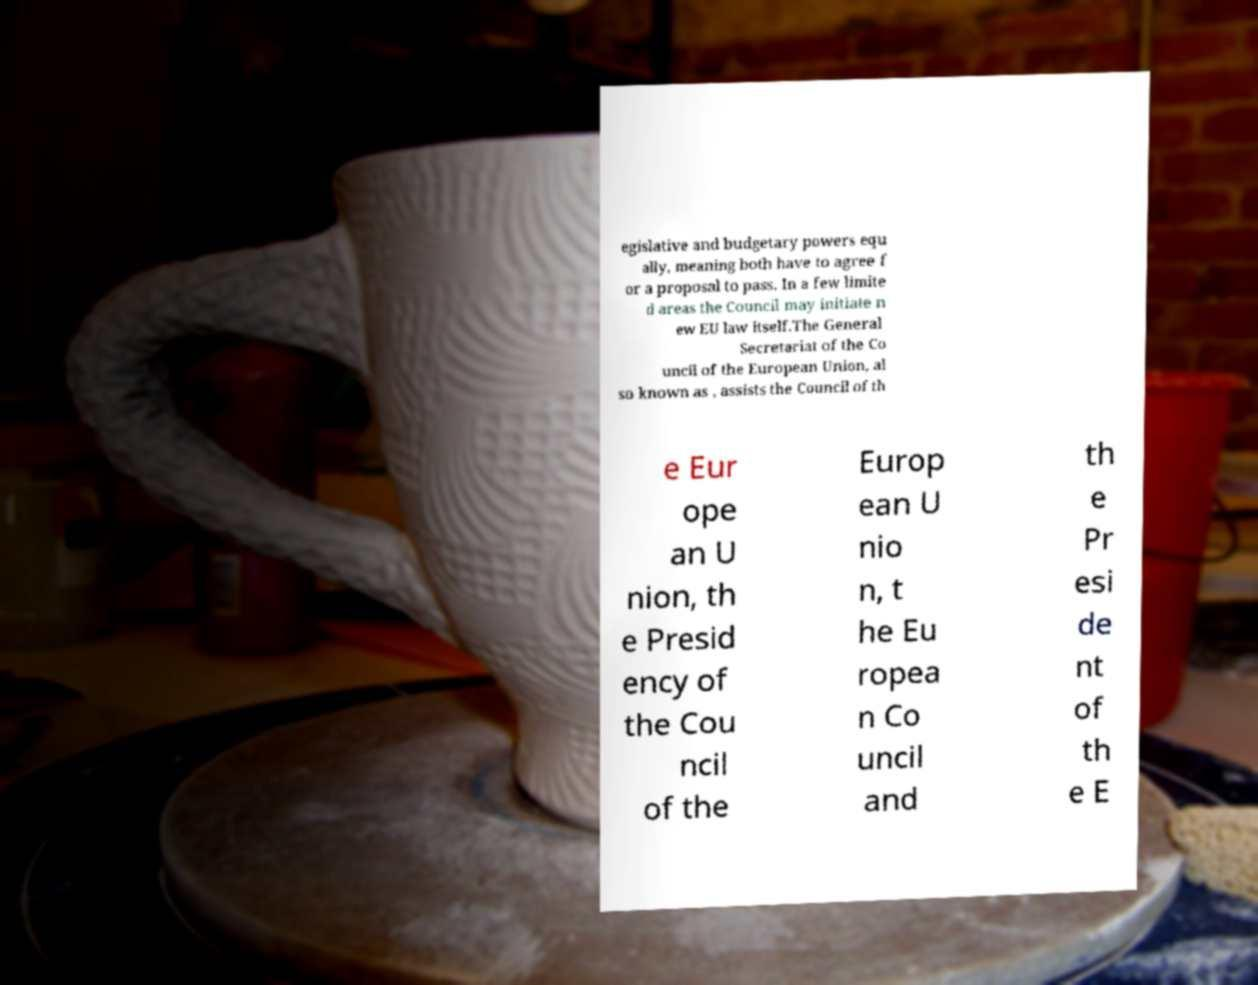Can you read and provide the text displayed in the image?This photo seems to have some interesting text. Can you extract and type it out for me? egislative and budgetary powers equ ally, meaning both have to agree f or a proposal to pass. In a few limite d areas the Council may initiate n ew EU law itself.The General Secretariat of the Co uncil of the European Union, al so known as , assists the Council of th e Eur ope an U nion, th e Presid ency of the Cou ncil of the Europ ean U nio n, t he Eu ropea n Co uncil and th e Pr esi de nt of th e E 